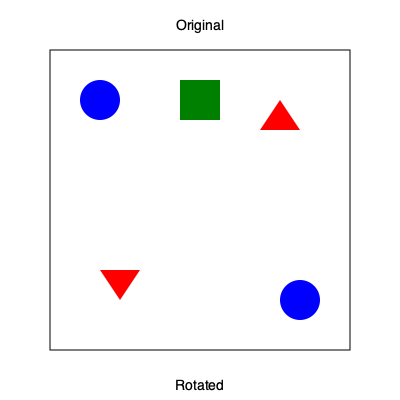The image shows three symbols representing emerging technologies: a blue circle (AI), a green square (blockchain), and a red triangle (gene editing). If the bottom arrangement is a 90-degree clockwise rotation of the top arrangement, which technology symbol has been misplaced, potentially altering the interpretation of its impact on human rights legislation? To solve this problem, we need to mentally rotate the original arrangement 90 degrees clockwise and compare it with the given rotated arrangement. Let's go through this step-by-step:

1. The blue circle (AI):
   - Original position: top-left
   - After 90-degree clockwise rotation: bottom-left
   - Given position in rotated arrangement: bottom-right
   - Conclusion: Correctly placed

2. The green square (blockchain):
   - Original position: top-center
   - After 90-degree clockwise rotation: center-right
   - Given position in rotated arrangement: center-right, but rotated 90 degrees
   - Conclusion: Correctly placed and orientation is consistent

3. The red triangle (gene editing):
   - Original position: top-right
   - After 90-degree clockwise rotation: bottom-right
   - Given position in rotated arrangement: bottom-left
   - Conclusion: Incorrectly placed

The red triangle (gene editing) symbol is in the wrong position after rotation. This misplacement could lead to misinterpretation of the relationship between gene editing technology and other emerging technologies in the context of human rights legislation. For a human rights lawyer, this error could signify a need for careful consideration of how gene editing interacts with AI and blockchain in shaping future legal frameworks.
Answer: Gene editing (red triangle) 